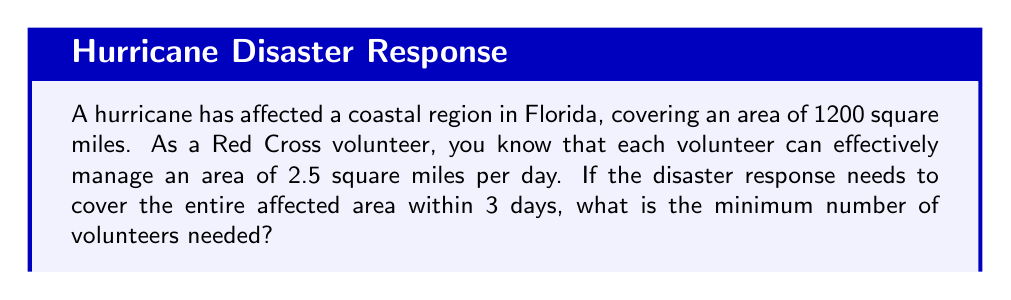Provide a solution to this math problem. Let's approach this step-by-step:

1. Define variables:
   Let $x$ be the number of volunteers needed.

2. Calculate the total area that needs to be covered in 3 days:
   Total area = 1200 square miles

3. Calculate the area that can be covered by one volunteer in 3 days:
   Area per volunteer = 2.5 square miles/day × 3 days = 7.5 square miles

4. Set up an inequality:
   The total area covered by all volunteers should be greater than or equal to the affected area.
   $$7.5x \geq 1200$$

5. Solve the inequality:
   $$x \geq \frac{1200}{7.5} = 160$$

6. Since we need the minimum number of volunteers and $x$ represents people, we need to round up to the nearest whole number.

Therefore, the minimum number of volunteers needed is 160.
Answer: 160 volunteers 